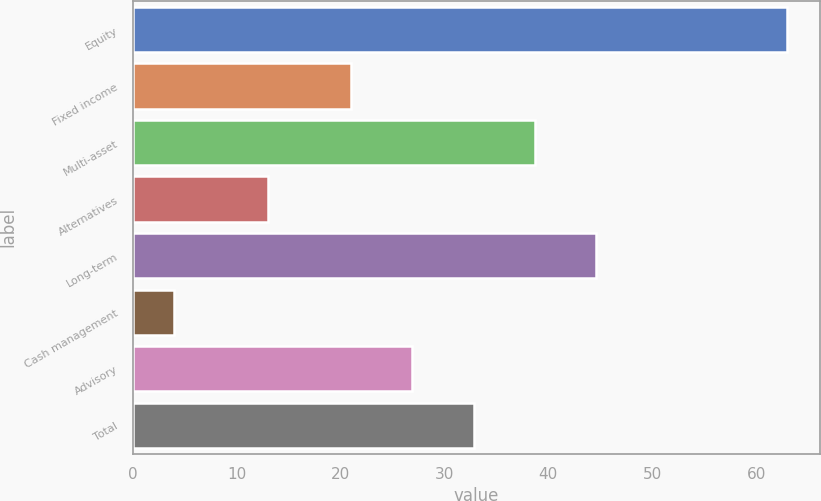Convert chart. <chart><loc_0><loc_0><loc_500><loc_500><bar_chart><fcel>Equity<fcel>Fixed income<fcel>Multi-asset<fcel>Alternatives<fcel>Long-term<fcel>Cash management<fcel>Advisory<fcel>Total<nl><fcel>63<fcel>21<fcel>38.7<fcel>13<fcel>44.6<fcel>4<fcel>26.9<fcel>32.8<nl></chart> 